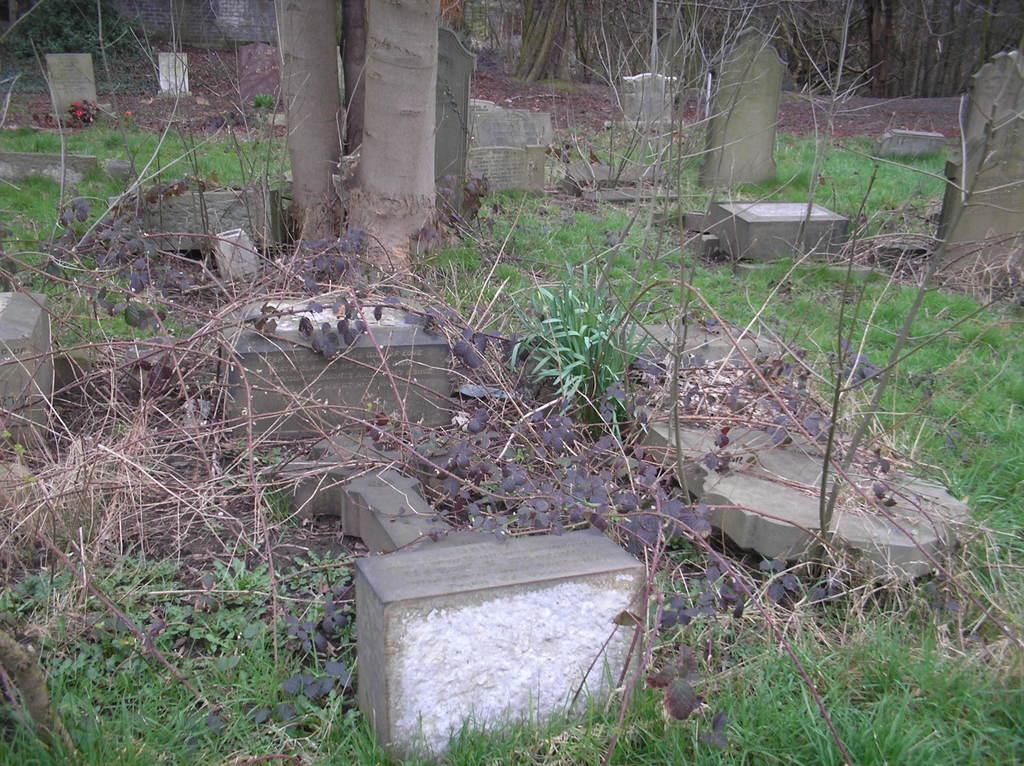Where was the image taken? The image was taken in a cemetery. What type of vegetation can be seen in the image? There are plants, trees, and grass visible in the image. What are the main structures in the image? There are gravestones in the image. What is visible at the top of the image? Trees are visible at the top of the image. What type of oil can be seen dripping from the gravestone in the image? There is no oil present in the image, and no substance is dripping from the gravestones. Can you provide any advice on how to fold the plants in the image? There is no need to fold the plants in the image, as they are living organisms and not meant to be folded. 